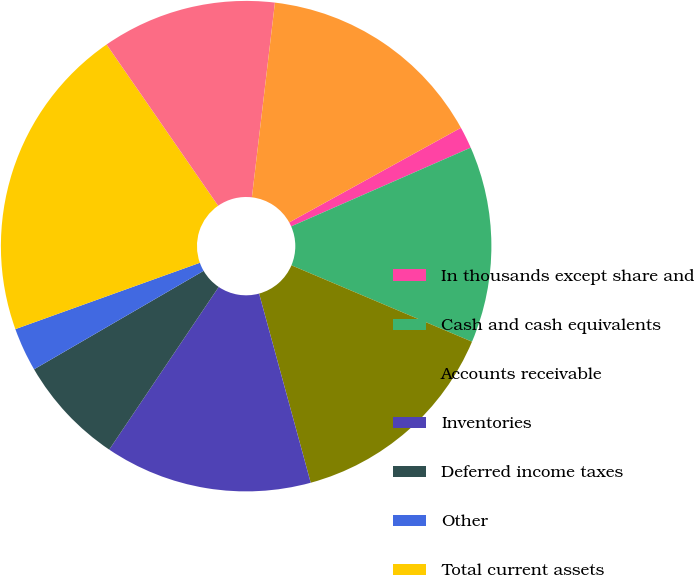Convert chart to OTSL. <chart><loc_0><loc_0><loc_500><loc_500><pie_chart><fcel>In thousands except share and<fcel>Cash and cash equivalents<fcel>Accounts receivable<fcel>Inventories<fcel>Deferred income taxes<fcel>Other<fcel>Total current assets<fcel>Property plant and equipment<fcel>Accumulated depreciation<nl><fcel>1.44%<fcel>12.95%<fcel>14.39%<fcel>13.67%<fcel>7.2%<fcel>2.88%<fcel>20.86%<fcel>11.51%<fcel>15.11%<nl></chart> 